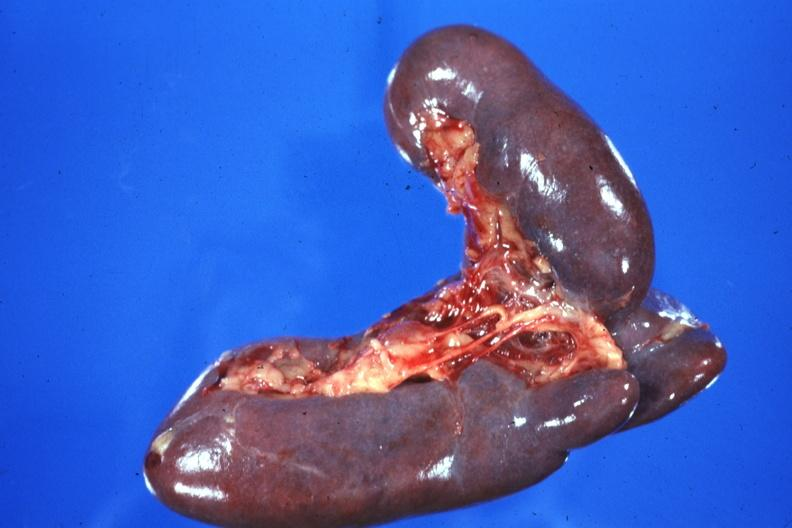what is present?
Answer the question using a single word or phrase. Bilobed 